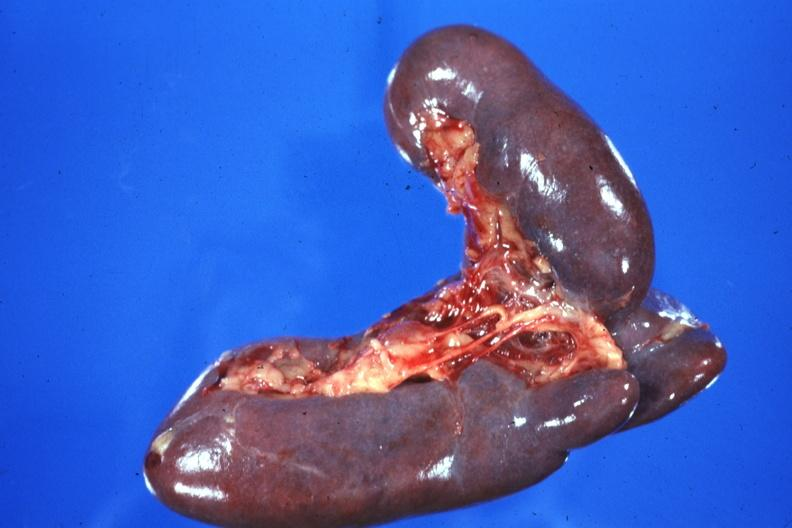what is present?
Answer the question using a single word or phrase. Bilobed 